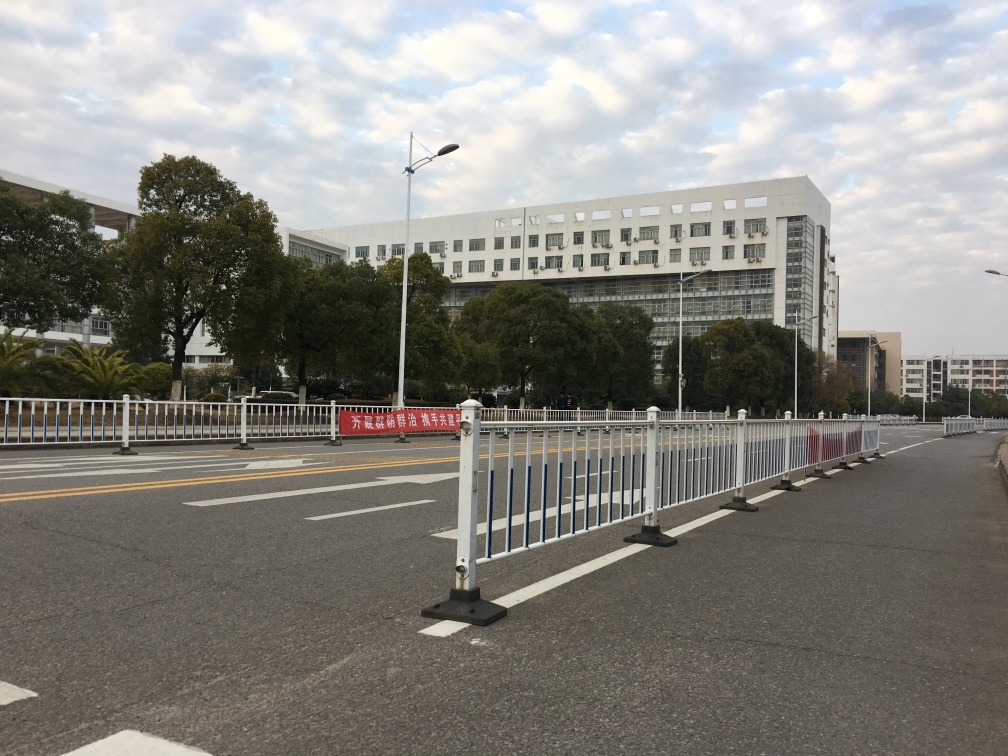Are there any focusing issues in the image?
 No 